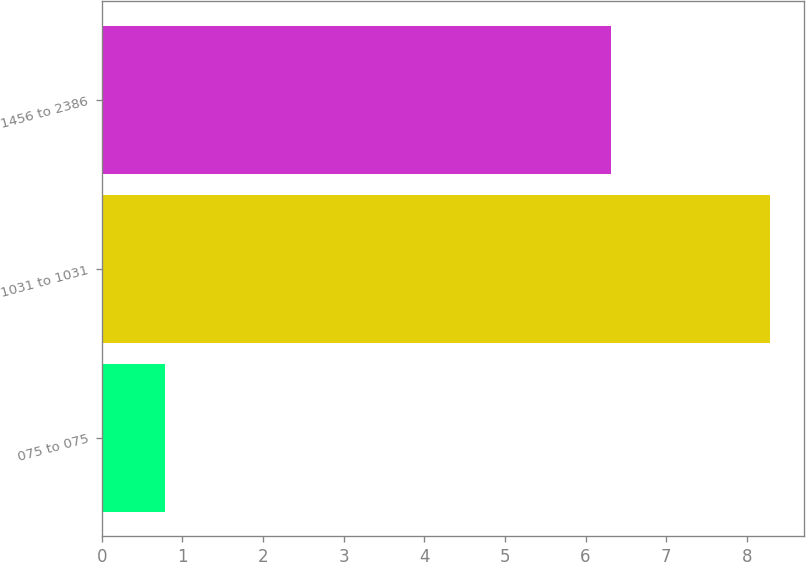Convert chart to OTSL. <chart><loc_0><loc_0><loc_500><loc_500><bar_chart><fcel>075 to 075<fcel>1031 to 1031<fcel>1456 to 2386<nl><fcel>0.78<fcel>8.29<fcel>6.31<nl></chart> 